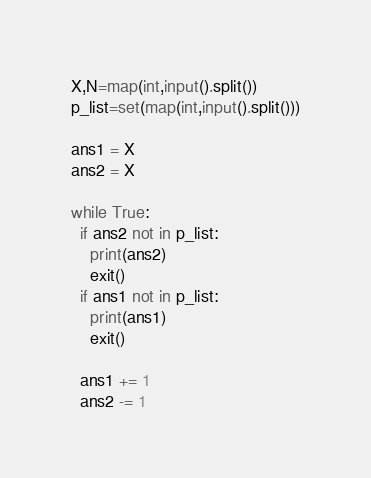Convert code to text. <code><loc_0><loc_0><loc_500><loc_500><_Python_>X,N=map(int,input().split())
p_list=set(map(int,input().split()))

ans1 = X
ans2 = X

while True:
  if ans2 not in p_list:
    print(ans2)
    exit()
  if ans1 not in p_list:
    print(ans1)
    exit()

  ans1 += 1
  ans2 -= 1
</code> 